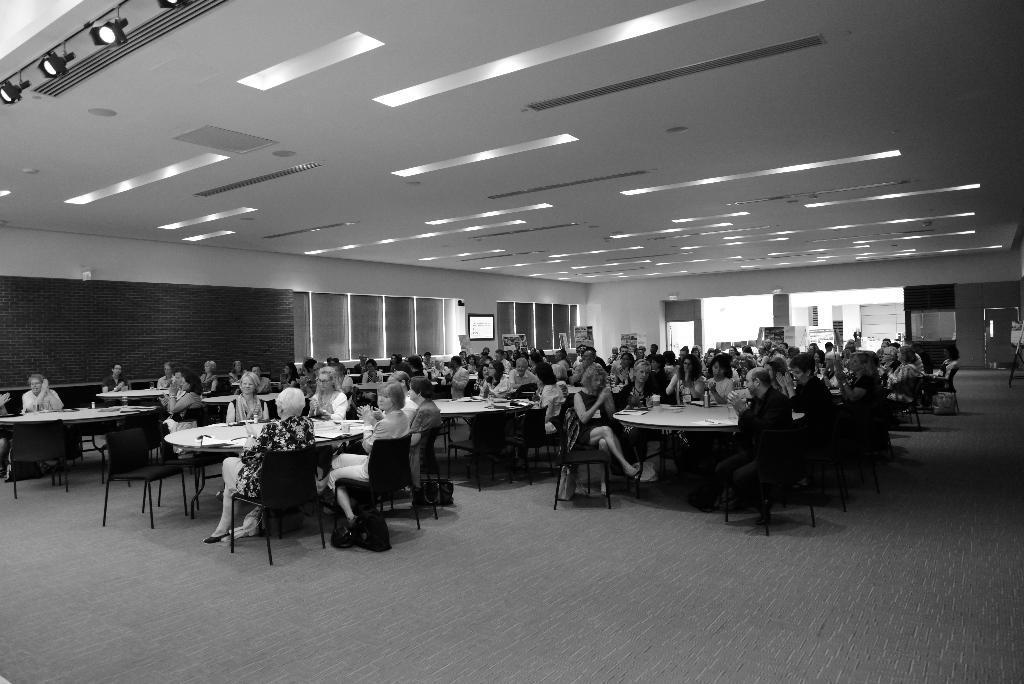How would you summarize this image in a sentence or two? This is a black and white image. In this image we can see many persons sitting on the chairs at the tables. In the background we can see windows, lights, doors, screens and wall. 